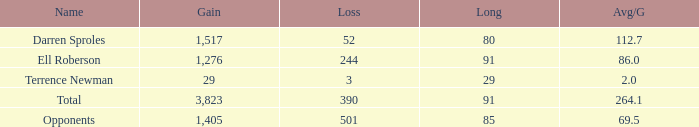Help me parse the entirety of this table. {'header': ['Name', 'Gain', 'Loss', 'Long', 'Avg/G'], 'rows': [['Darren Sproles', '1,517', '52', '80', '112.7'], ['Ell Roberson', '1,276', '244', '91', '86.0'], ['Terrence Newman', '29', '3', '29', '2.0'], ['Total', '3,823', '390', '91', '264.1'], ['Opponents', '1,405', '501', '85', '69.5']]} When the player gained below 1,405 yards and lost over 390 yards, what's the sum of the long yards? None. 